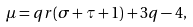<formula> <loc_0><loc_0><loc_500><loc_500>\mu = q r ( \sigma + \tau + 1 ) + 3 q - 4 ,</formula> 